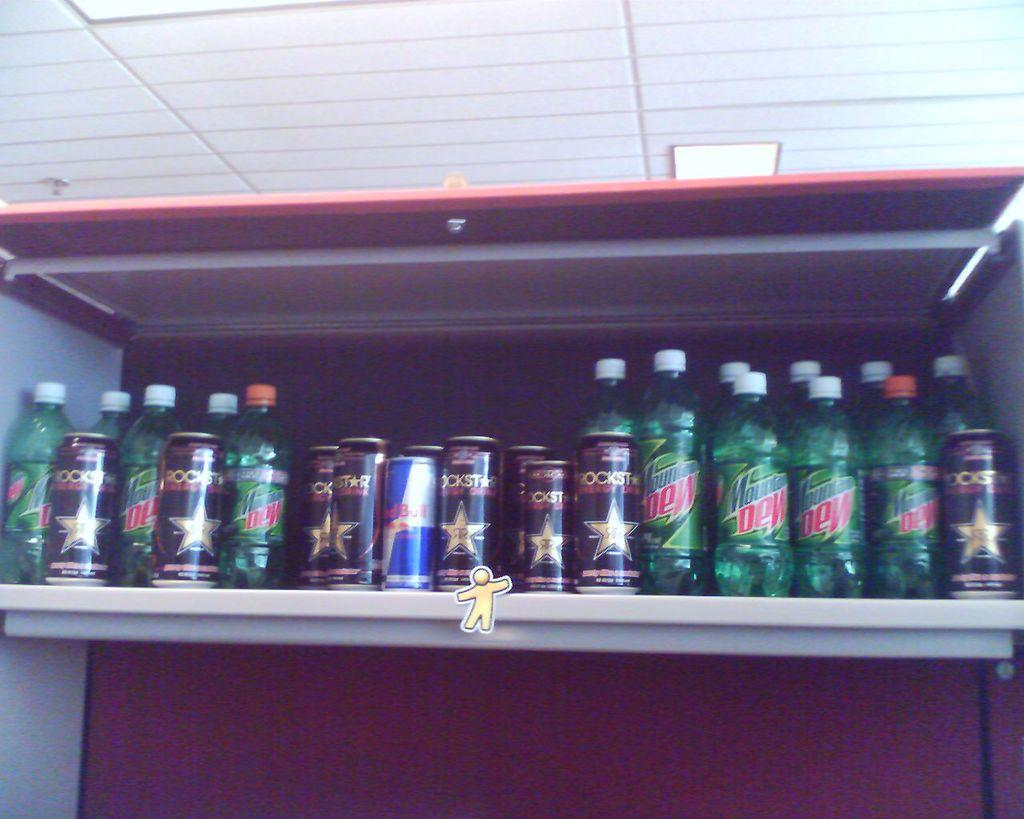<image>
Write a terse but informative summary of the picture. a shelf of drinks, including mountain dew, redbull, and rockstar 